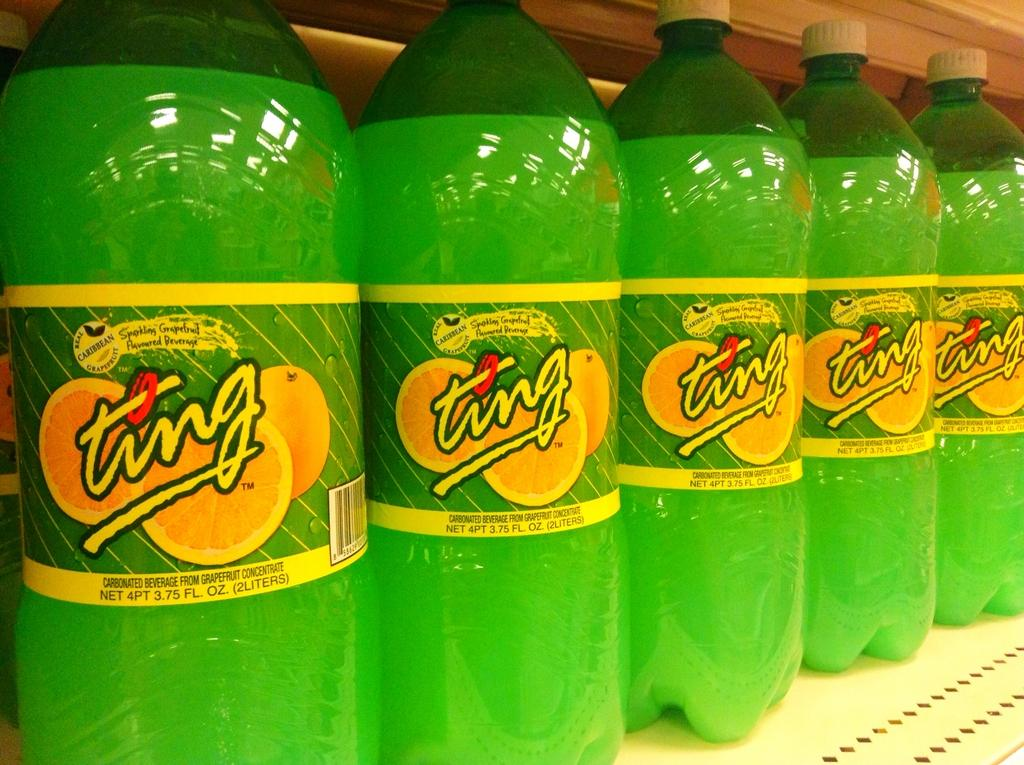Provide a one-sentence caption for the provided image. A white shelf full of green sodas called Ting. 